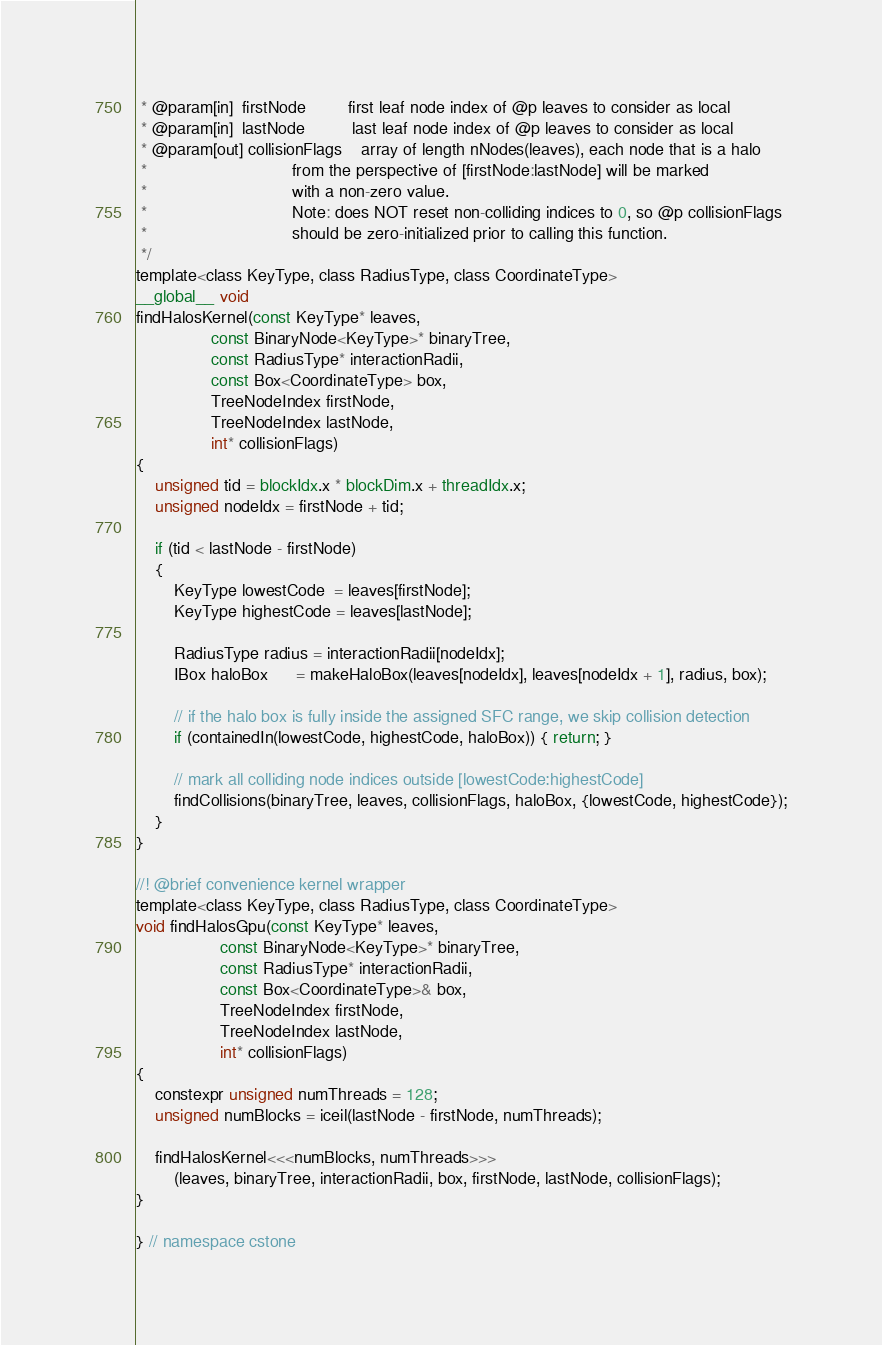<code> <loc_0><loc_0><loc_500><loc_500><_Cuda_> * @param[in]  firstNode         first leaf node index of @p leaves to consider as local
 * @param[in]  lastNode          last leaf node index of @p leaves to consider as local
 * @param[out] collisionFlags    array of length nNodes(leaves), each node that is a halo
 *                               from the perspective of [firstNode:lastNode] will be marked
 *                               with a non-zero value.
 *                               Note: does NOT reset non-colliding indices to 0, so @p collisionFlags
 *                               should be zero-initialized prior to calling this function.
 */
template<class KeyType, class RadiusType, class CoordinateType>
__global__ void
findHalosKernel(const KeyType* leaves,
                const BinaryNode<KeyType>* binaryTree,
                const RadiusType* interactionRadii,
                const Box<CoordinateType> box,
                TreeNodeIndex firstNode,
                TreeNodeIndex lastNode,
                int* collisionFlags)
{
    unsigned tid = blockIdx.x * blockDim.x + threadIdx.x;
    unsigned nodeIdx = firstNode + tid;

    if (tid < lastNode - firstNode)
    {
        KeyType lowestCode  = leaves[firstNode];
        KeyType highestCode = leaves[lastNode];

        RadiusType radius = interactionRadii[nodeIdx];
        IBox haloBox      = makeHaloBox(leaves[nodeIdx], leaves[nodeIdx + 1], radius, box);

        // if the halo box is fully inside the assigned SFC range, we skip collision detection
        if (containedIn(lowestCode, highestCode, haloBox)) { return; }

        // mark all colliding node indices outside [lowestCode:highestCode]
        findCollisions(binaryTree, leaves, collisionFlags, haloBox, {lowestCode, highestCode});
    }
}

//! @brief convenience kernel wrapper
template<class KeyType, class RadiusType, class CoordinateType>
void findHalosGpu(const KeyType* leaves,
                  const BinaryNode<KeyType>* binaryTree,
                  const RadiusType* interactionRadii,
                  const Box<CoordinateType>& box,
                  TreeNodeIndex firstNode,
                  TreeNodeIndex lastNode,
                  int* collisionFlags)
{
    constexpr unsigned numThreads = 128;
    unsigned numBlocks = iceil(lastNode - firstNode, numThreads);

    findHalosKernel<<<numBlocks, numThreads>>>
        (leaves, binaryTree, interactionRadii, box, firstNode, lastNode, collisionFlags);
}

} // namespace cstone
</code> 